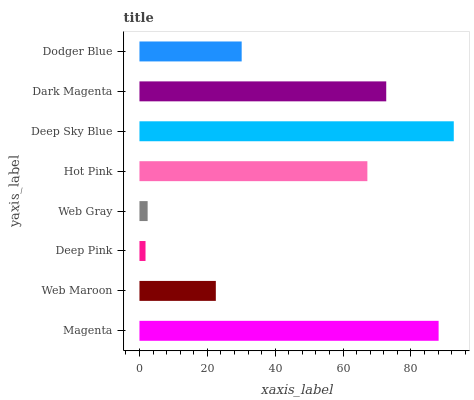Is Deep Pink the minimum?
Answer yes or no. Yes. Is Deep Sky Blue the maximum?
Answer yes or no. Yes. Is Web Maroon the minimum?
Answer yes or no. No. Is Web Maroon the maximum?
Answer yes or no. No. Is Magenta greater than Web Maroon?
Answer yes or no. Yes. Is Web Maroon less than Magenta?
Answer yes or no. Yes. Is Web Maroon greater than Magenta?
Answer yes or no. No. Is Magenta less than Web Maroon?
Answer yes or no. No. Is Hot Pink the high median?
Answer yes or no. Yes. Is Dodger Blue the low median?
Answer yes or no. Yes. Is Deep Pink the high median?
Answer yes or no. No. Is Web Gray the low median?
Answer yes or no. No. 